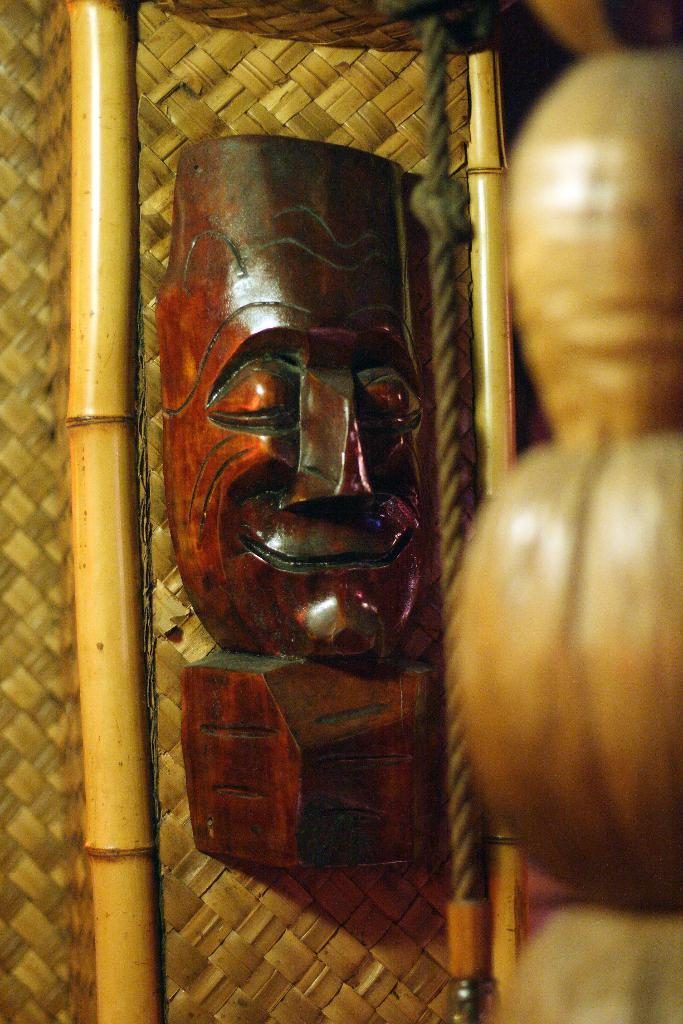What is the main object in the image? There is a mask in the image. What material is the mask made of? The mask is made of wood. How is the mask connected to another object? The mask is attached to a wooden mat. What are the two long, thin objects in the image? There are two sticks in the image. Where are the objects located in the image? The objects are on the right side of the image. How much sugar is on the desk in the image? There is no desk or sugar present in the image. What type of base is supporting the mask in the image? The mask is attached to a wooden mat, and there is no separate base supporting it. 